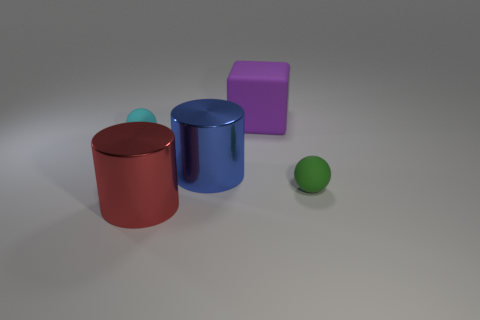What lighting conditions are present in this scene? The lighting in the scene appears to be diffuse, with soft shadows indicating that the light source is not strongly directional and is perhaps simulating an overcast sky or indoor ambient lighting. 